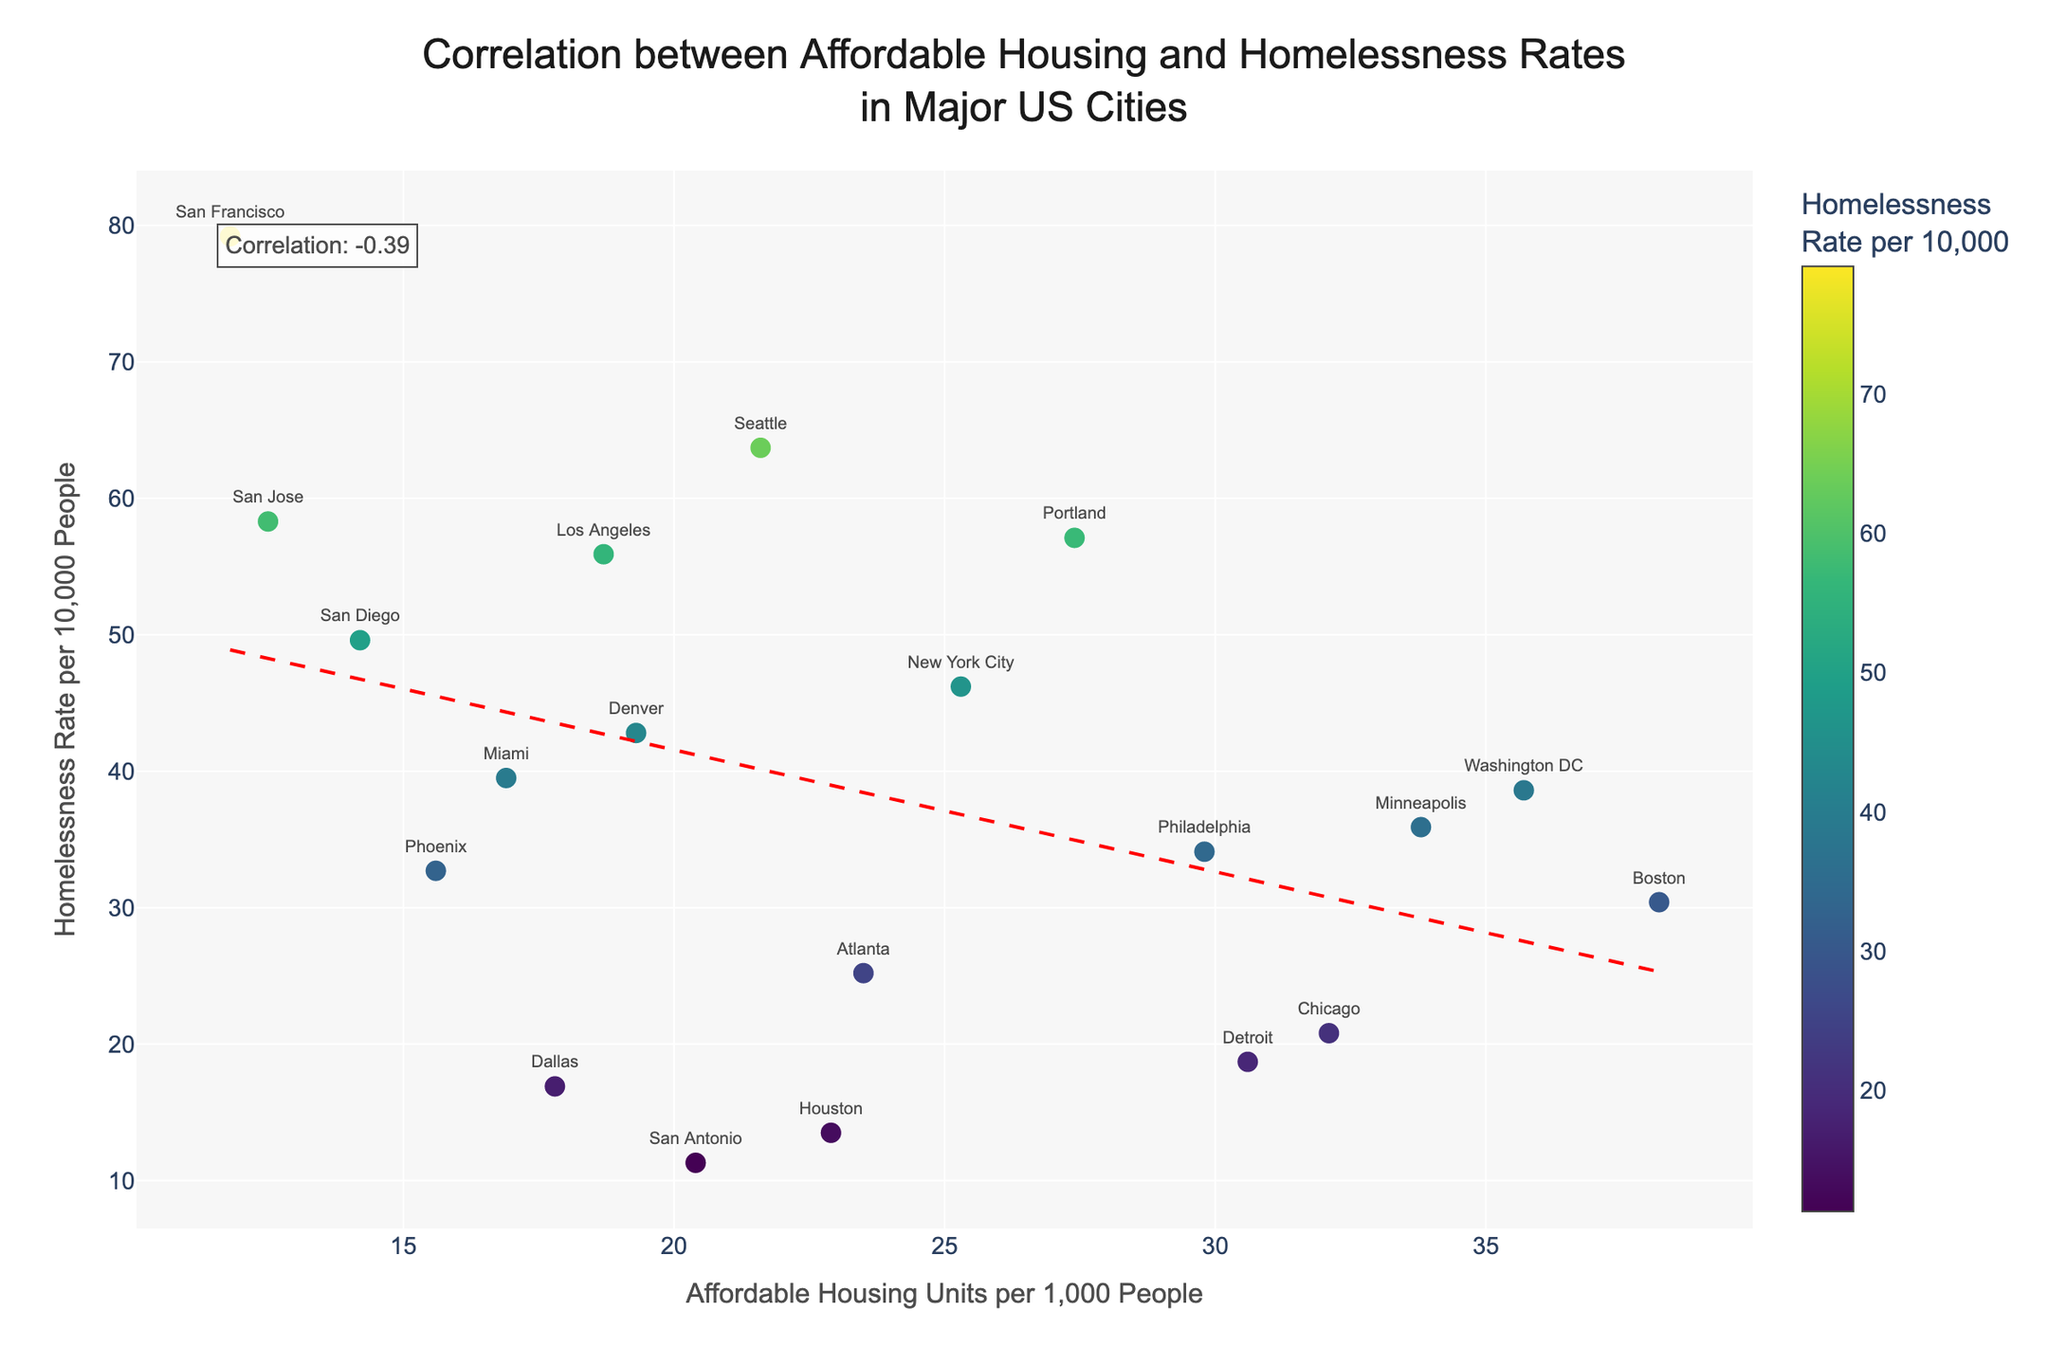What's the title of the figure? The title of a figure is usually displayed prominently at the top. In this case, it is clearly written above the plot area.
Answer: Correlation between Affordable Housing and Homelessness Rates in Major US Cities What are the units on the x-axis? Look at the label of the x-axis, which describes the units used for the data points along this axis.
Answer: Affordable Housing Units per 1,000 People Which city has the highest homelessness rate? Identify the y-axis to understand it represents homelessness rates. Then find the highest point on this axis and check the associated city label near the data point.
Answer: San Francisco How many cities are plotted in the figure? Count the number of unique city names provided next to each data point in the scatter plot.
Answer: 19 Which city has the lowest affordable housing units per 1,000 people? Identify the x-axis to understand it displays affordable housing units. Look for the lowest value along this axis and find the corresponding city label.
Answer: San Francisco What is the correlation between affordable housing and homelessness rates? Look for the annotation within the scatter plot that explicitly states the correlation value.
Answer: -0.59 What trend does the red dashed line represent? The red dashed line represents a trendline, often a linear fit. It indicates the general direction or relationship between the two variables.
Answer: Negative correlation Which city has the closest affordable housing units to the average value for all cities? First, calculate the average affordable housing units per 1,000 by summing all the values and dividing by 19. Then find the city with the closest value to this average on the scatter plot. (Average: (11.8+14.2+15.6+16.9+17.8+18.7+19.3+20.4+21.6+22.9+23.5+25.3+27.4+29.8+30.6+32.1+33.8+35.7+38.2)/19 = 23.27)
Answer: Atlanta Compare homelessness rates between Los Angeles and Washington DC. Identify the data points labeled 'Los Angeles' and 'Washington DC' on the scatter plot. Observe and compare their y-axis values, which represent homelessness rates.
Answer: Los Angeles has a higher homelessness rate than Washington DC Which city has more affordable housing units: Dallas or Phoenix? Find the data points labeled 'Dallas' and 'Phoenix', then compare their x-axis values, which represent affordable housing units.
Answer: Dallas 